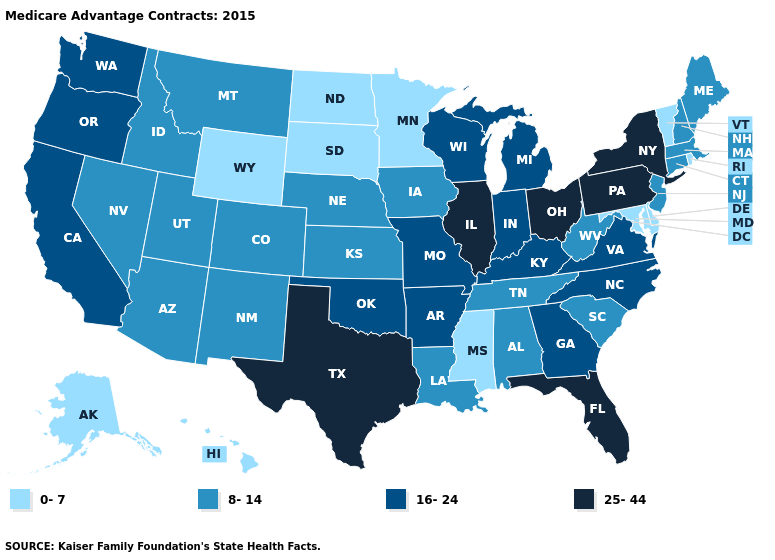What is the value of Mississippi?
Concise answer only. 0-7. Which states have the lowest value in the USA?
Short answer required. Alaska, Delaware, Hawaii, Maryland, Minnesota, Mississippi, North Dakota, Rhode Island, South Dakota, Vermont, Wyoming. What is the value of Montana?
Keep it brief. 8-14. Name the states that have a value in the range 8-14?
Be succinct. Alabama, Arizona, Colorado, Connecticut, Iowa, Idaho, Kansas, Louisiana, Massachusetts, Maine, Montana, Nebraska, New Hampshire, New Jersey, New Mexico, Nevada, South Carolina, Tennessee, Utah, West Virginia. Name the states that have a value in the range 16-24?
Concise answer only. Arkansas, California, Georgia, Indiana, Kentucky, Michigan, Missouri, North Carolina, Oklahoma, Oregon, Virginia, Washington, Wisconsin. Which states have the lowest value in the USA?
Write a very short answer. Alaska, Delaware, Hawaii, Maryland, Minnesota, Mississippi, North Dakota, Rhode Island, South Dakota, Vermont, Wyoming. What is the value of Missouri?
Give a very brief answer. 16-24. Which states have the lowest value in the USA?
Answer briefly. Alaska, Delaware, Hawaii, Maryland, Minnesota, Mississippi, North Dakota, Rhode Island, South Dakota, Vermont, Wyoming. Name the states that have a value in the range 25-44?
Keep it brief. Florida, Illinois, New York, Ohio, Pennsylvania, Texas. How many symbols are there in the legend?
Quick response, please. 4. What is the highest value in the West ?
Quick response, please. 16-24. Among the states that border New York , which have the lowest value?
Keep it brief. Vermont. What is the value of New Hampshire?
Quick response, please. 8-14. Which states have the lowest value in the USA?
Be succinct. Alaska, Delaware, Hawaii, Maryland, Minnesota, Mississippi, North Dakota, Rhode Island, South Dakota, Vermont, Wyoming. Does Pennsylvania have the same value as New York?
Be succinct. Yes. 